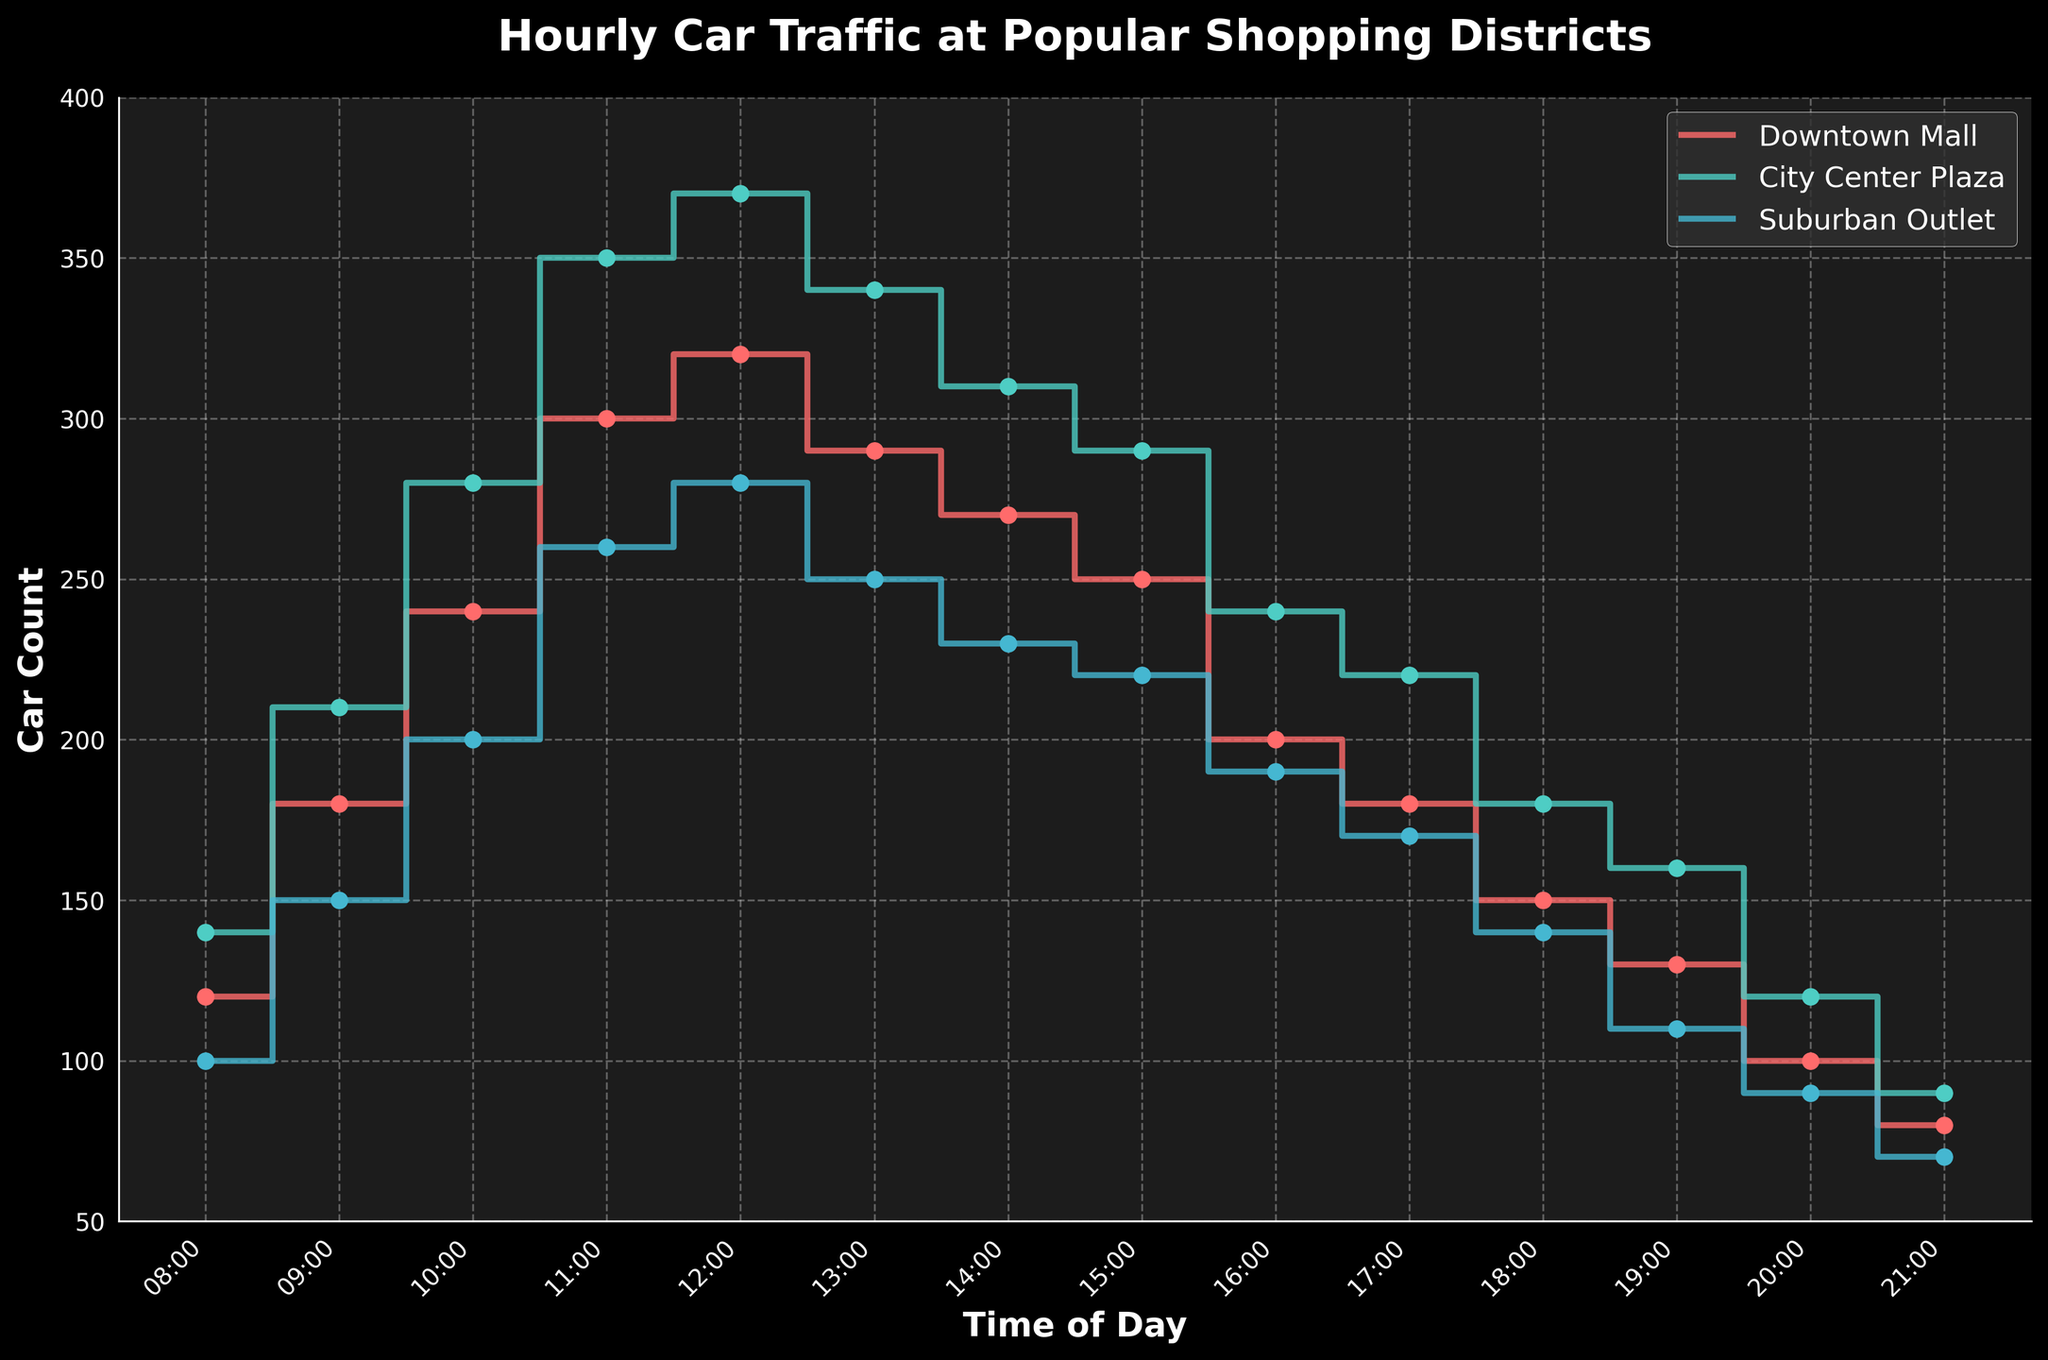How many shopping districts are shown in the plot? The plot shows data lines for each shopping district, and there are three distinct lines, each with its own label: Downtown Mall, City Center Plaza, and Suburban Outlet.
Answer: Three What's the highest car count recorded throughout the day? Look at the highest points in the figure across all three lines. The highest car count is at City Center Plaza at 12:00 with a count of 370.
Answer: 370 At what time does Downtown Mall first exceed 200 cars? Examine the Downtown Mall line to find the first time it crosses the 200-car mark. This happens at 10:00.
Answer: 10:00 Compare the car counts at 14:00 for all three districts. Which one has the highest count? At 14:00, the car counts for Downtown Mall, City Center Plaza, and Suburban Outlet are respectively 270, 310, and 230. The highest car count is at City Center Plaza.
Answer: City Center Plaza Which district has the lowest car count at 21:00? At 21:00, check the car counts for all districts. The counts are 80 for Downtown Mall, 90 for City Center Plaza, and 70 for Suburban Outlet. The lowest count is at Suburban Outlet.
Answer: Suburban Outlet What's the total car count for Suburban Outlet from 08:00 to 20:00? Sum the car counts from each hour for Suburban Outlet between 08:00 and 20:00. The counts are 100 + 150 + 200 + 260 + 280 + 250 + 230 + 220 + 190 + 170 + 140 + 110 + 90 = 2390.
Answer: 2390 How many times does the City Center Plaza line dip below 200 cars? Count the occurrences where the City Center Plaza line falls below 200 cars throughout the day. This happens twice: once at 20:00 and once at 21:00.
Answer: Twice What's the average car count between 12:00 and 16:00 for Downtown Mall? Average the car counts for Downtown Mall from 12:00 to 16:00. The counts are 320, 290, 270, and 250. Sum these to get 1130 and divide by the number of hours (4). The average is 1130 / 4 = 282.5.
Answer: 282.5 